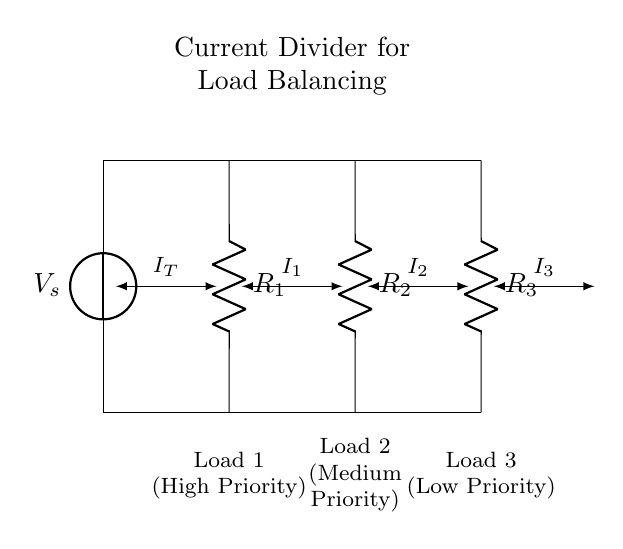What is the total current entering the circuit? The total current, denoted as \(I_T\), is the sum of the currents flowing through each parallel resistor. The circuit diagram does not specify numerical values for currents, but \(I_T\) represents the total incoming current, which is divided among the branches.
Answer: Total current \(I_T\) What are the components connected in parallel? The components connected in parallel are \(R_1\), \(R_2\), and \(R_3\). The diagram shows them branching from a common point at the top and rejoining at the bottom, which is characteristic of parallel circuits.
Answer: \(R_1\), \(R_2\), \(R_3\) Which load has the highest priority? Load 1, which is associated with \(R_1\), is labeled "High Priority." The circuit is designed to balance current across all loads, but priority indicates that it is intended to receive a proportionate share of the current.
Answer: Load 1 How does current divide among the branches? In a current divider, the current is inversely proportional to the resistance of each branch. Higher resistance results in lower current through that branch. Thus, to determine the individual currents \(I_1\), \(I_2\), and \(I_3\), one would apply the current divider rule based on their respective resistances.
Answer: Inversely proportional to resistance What is the relationship between the resistors and their currents? The relationship is defined by Ohm's law and the current divider principle. Specifically, the current through each resistor is determined by the formula \(I_n = I_T \times \frac{R_{total}}{R_n}\), where \(R_n\) is the resistance of the branch and \(R_{total}\) is the equivalent resistance of all parallel resistors combined. This shows how the load affects current distribution.
Answer: Based on Ohm's law and current divider rule 